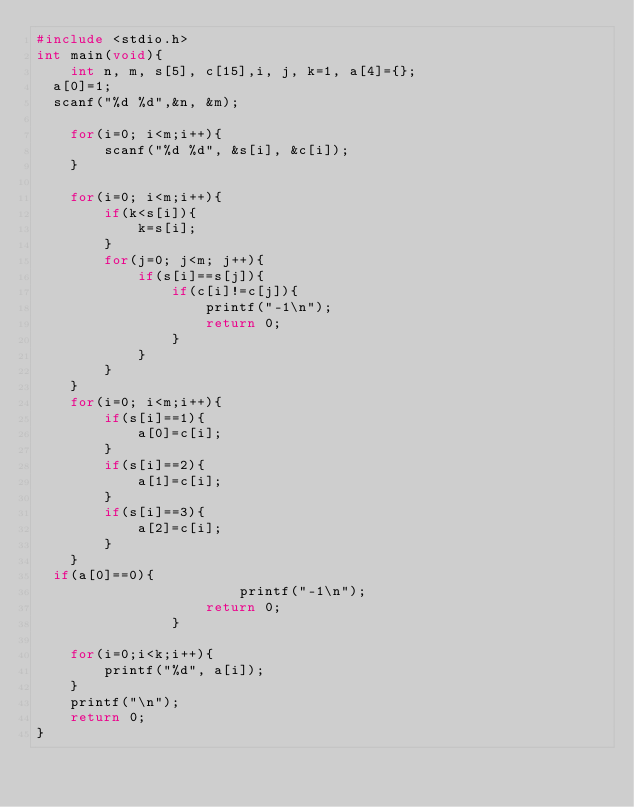Convert code to text. <code><loc_0><loc_0><loc_500><loc_500><_C_>#include <stdio.h>
int main(void){
	int n, m, s[5], c[15],i, j, k=1, a[4]={};
  a[0]=1;
  scanf("%d %d",&n, &m);
	
	for(i=0; i<m;i++){
		scanf("%d %d", &s[i], &c[i]);
	}
	
	for(i=0; i<m;i++){
		if(k<s[i]){
			k=s[i];
		}
		for(j=0; j<m; j++){
			if(s[i]==s[j]){
				if(c[i]!=c[j]){
					printf("-1\n");
					return 0;
				}
			}
		}
	}
	for(i=0; i<m;i++){
		if(s[i]==1){
			a[0]=c[i];
		}
		if(s[i]==2){
			a[1]=c[i];
		}
		if(s[i]==3){
			a[2]=c[i];
		}
	}
  if(a[0]==0){
    					printf("-1\n");
					return 0;
				}
    
	for(i=0;i<k;i++){
		printf("%d", a[i]);
	}
	printf("\n");
	return 0;
}</code> 